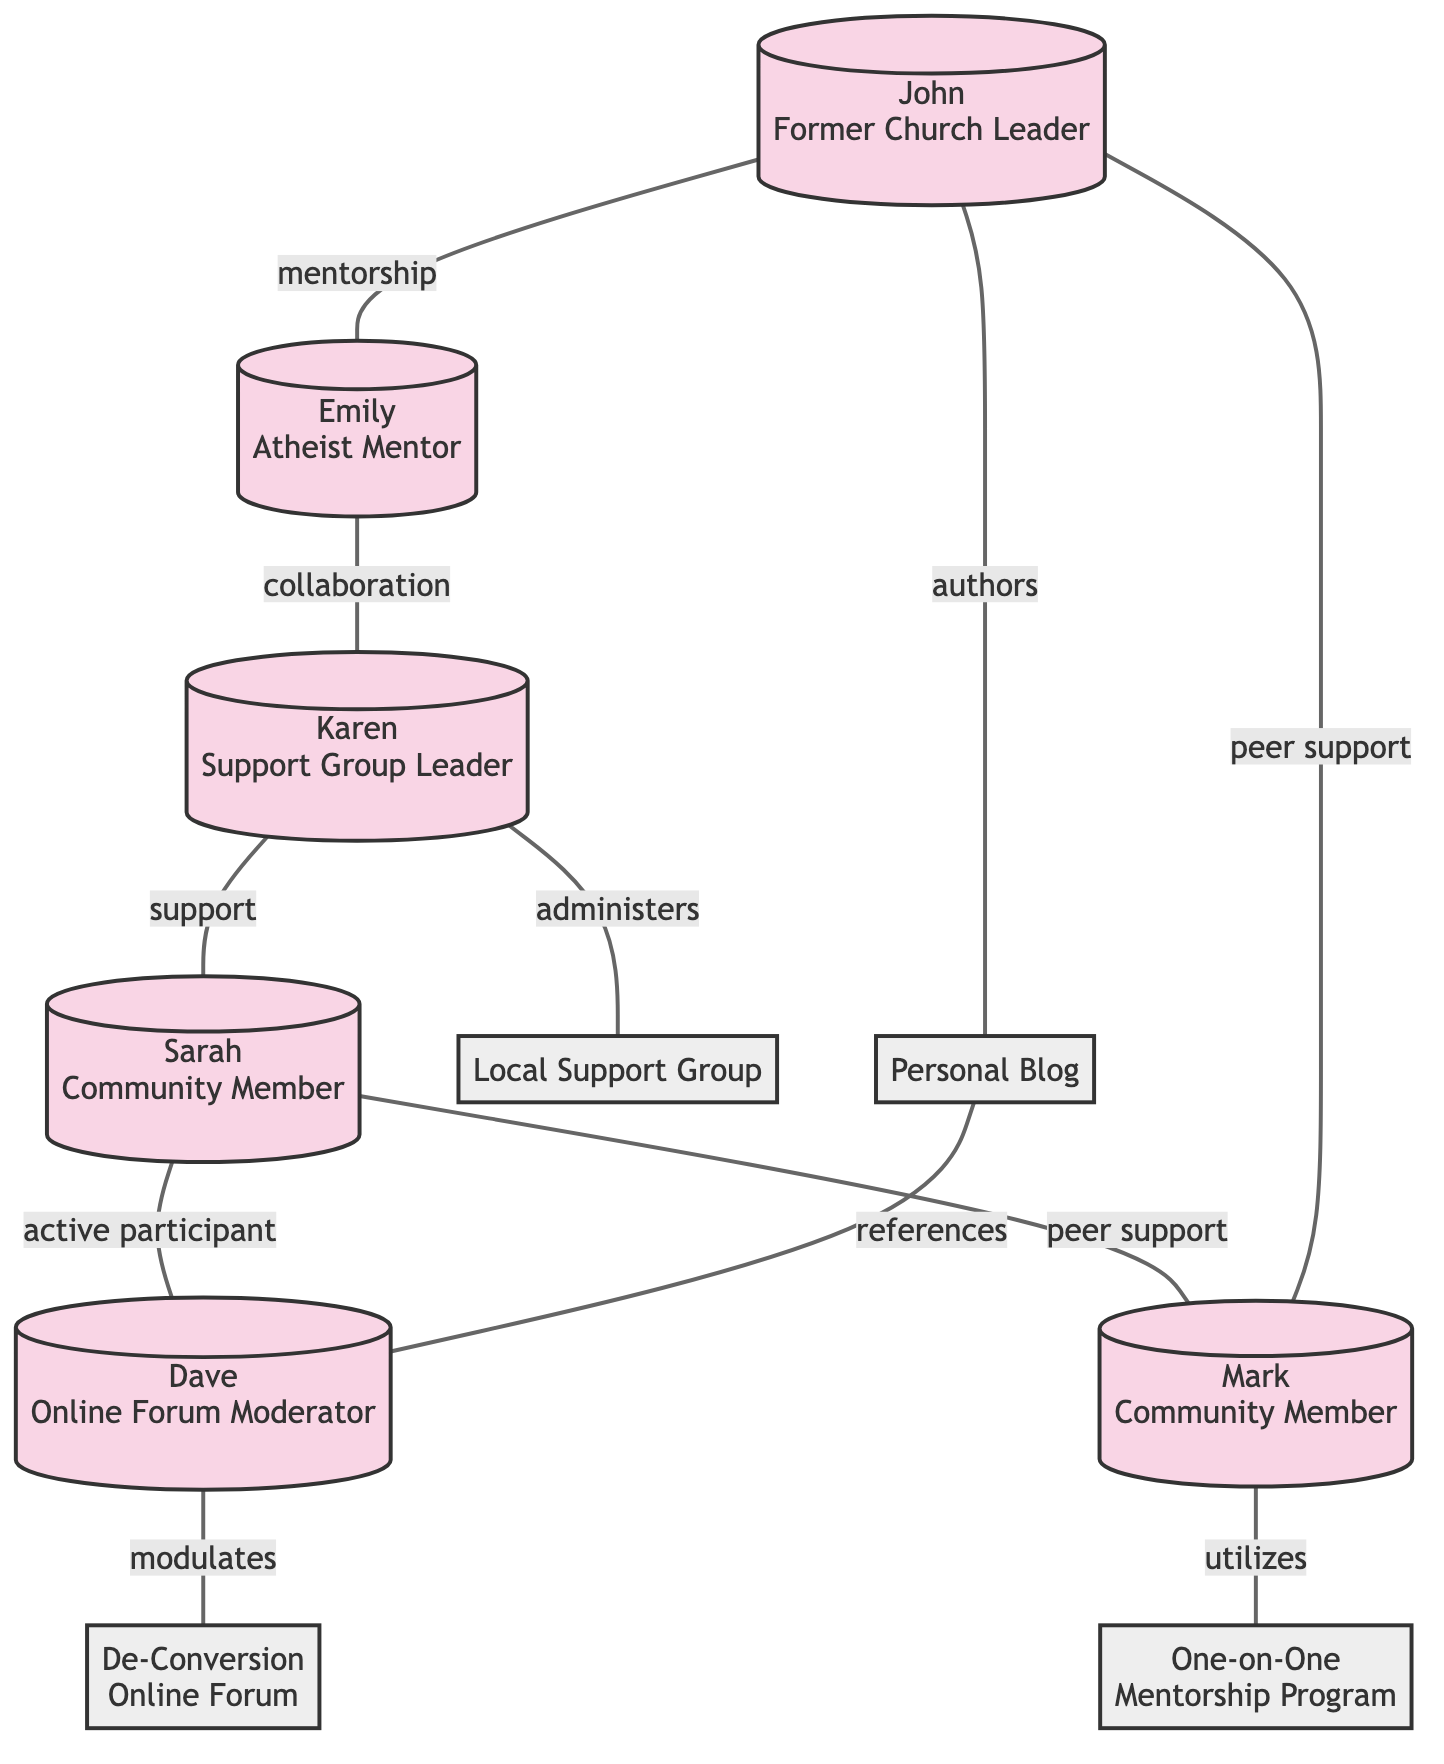What is the role of the node with ID 2? The node with ID 2 is labeled "Emily" and the role is "Atheist Mentor", which is stated in the diagram.
Answer: Atheist Mentor Who does John provide mentorship to? John is connected to Emily through a mentorship relationship, indicating that he provides mentorship to her as represented by the edge labeled "mentorship."
Answer: Emily How many resources are represented in the diagram? There are 4 resources identified in the diagram as nodes, which include "De-Conversion Online Forum," "Local Support Group," "One-on-One Mentorship Program," and "Personal Blog."
Answer: 4 Which individual administers the Local Support Group? The edge labeled "administers" connects Karen to the "Local Support Group," indicating that Karen is the one who administers it.
Answer: Karen What type of relationship exists between Sarah and Mark? Sarah and Mark are directly connected by an edge labeled "peer support," which describes the relationship between them as one providing support to the other.
Answer: peer support How does Mark utilize support from the resources? Mark is connected to the "One-on-One Mentorship Program" with an edge labeled "utilizes," showing that he makes use of this resource for support.
Answer: One-on-One Mentorship Program Which node is referenced in the Personal Blog? The edge labeled "references" shows that the Personal Blog does reference the Online Forum Moderator, Dave, indicating he is the node being referenced.
Answer: Dave Who collaborates with Emily? The diagram shows that Emily collaborates with Karen, as indicated by the edge labeled "collaboration" connecting these two nodes.
Answer: Karen Identify the total number of interactions (edges) in the diagram. Counting all the connections (edges) between nodes—including mentorship, support, utilization, and collaboration—there are 10 edges in total shown in the diagram.
Answer: 10 